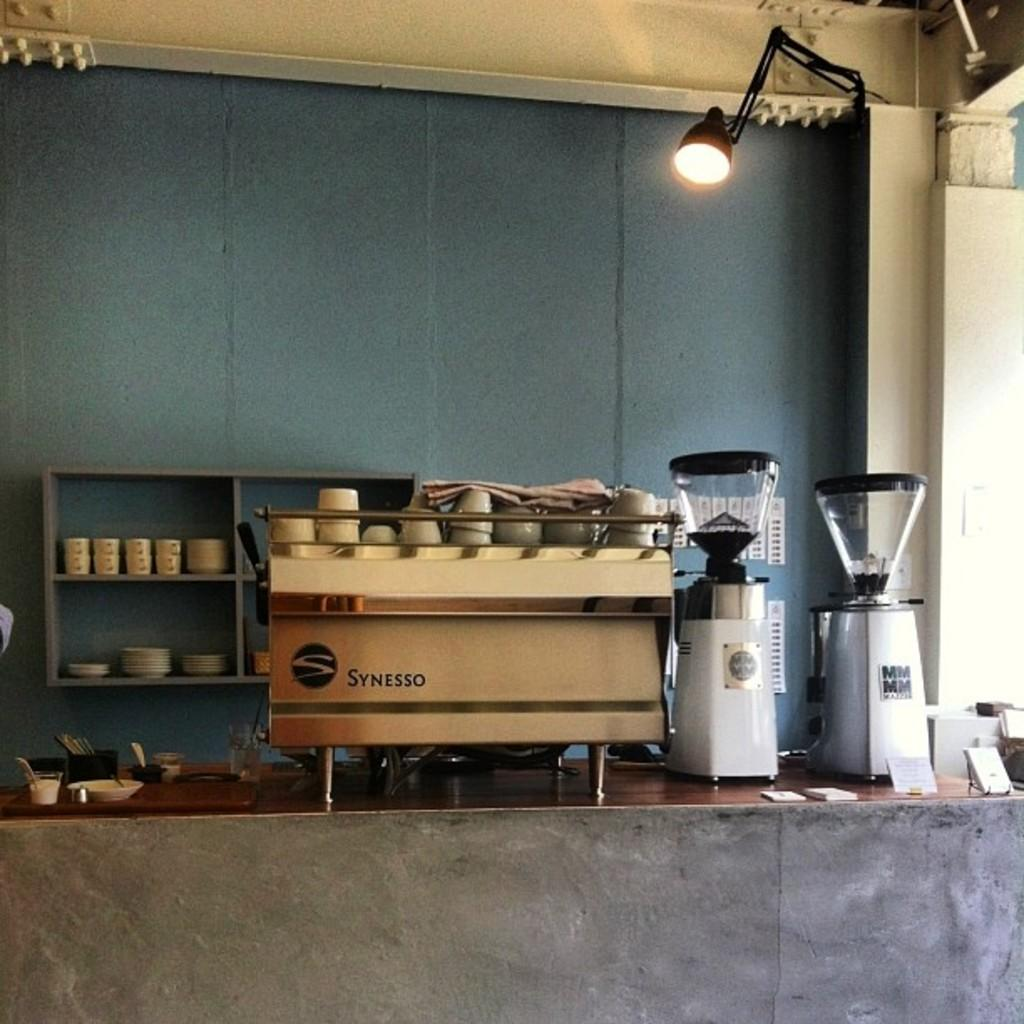<image>
Create a compact narrative representing the image presented. The coffee shop has a Synesso espresso machine with cups stacked on top. 